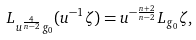<formula> <loc_0><loc_0><loc_500><loc_500>L _ { u ^ { \frac { 4 } { n - 2 } } g _ { 0 } } ( u ^ { - 1 } \zeta ) = u ^ { - \frac { n + 2 } { n - 2 } } L _ { g _ { 0 } } \zeta ,</formula> 